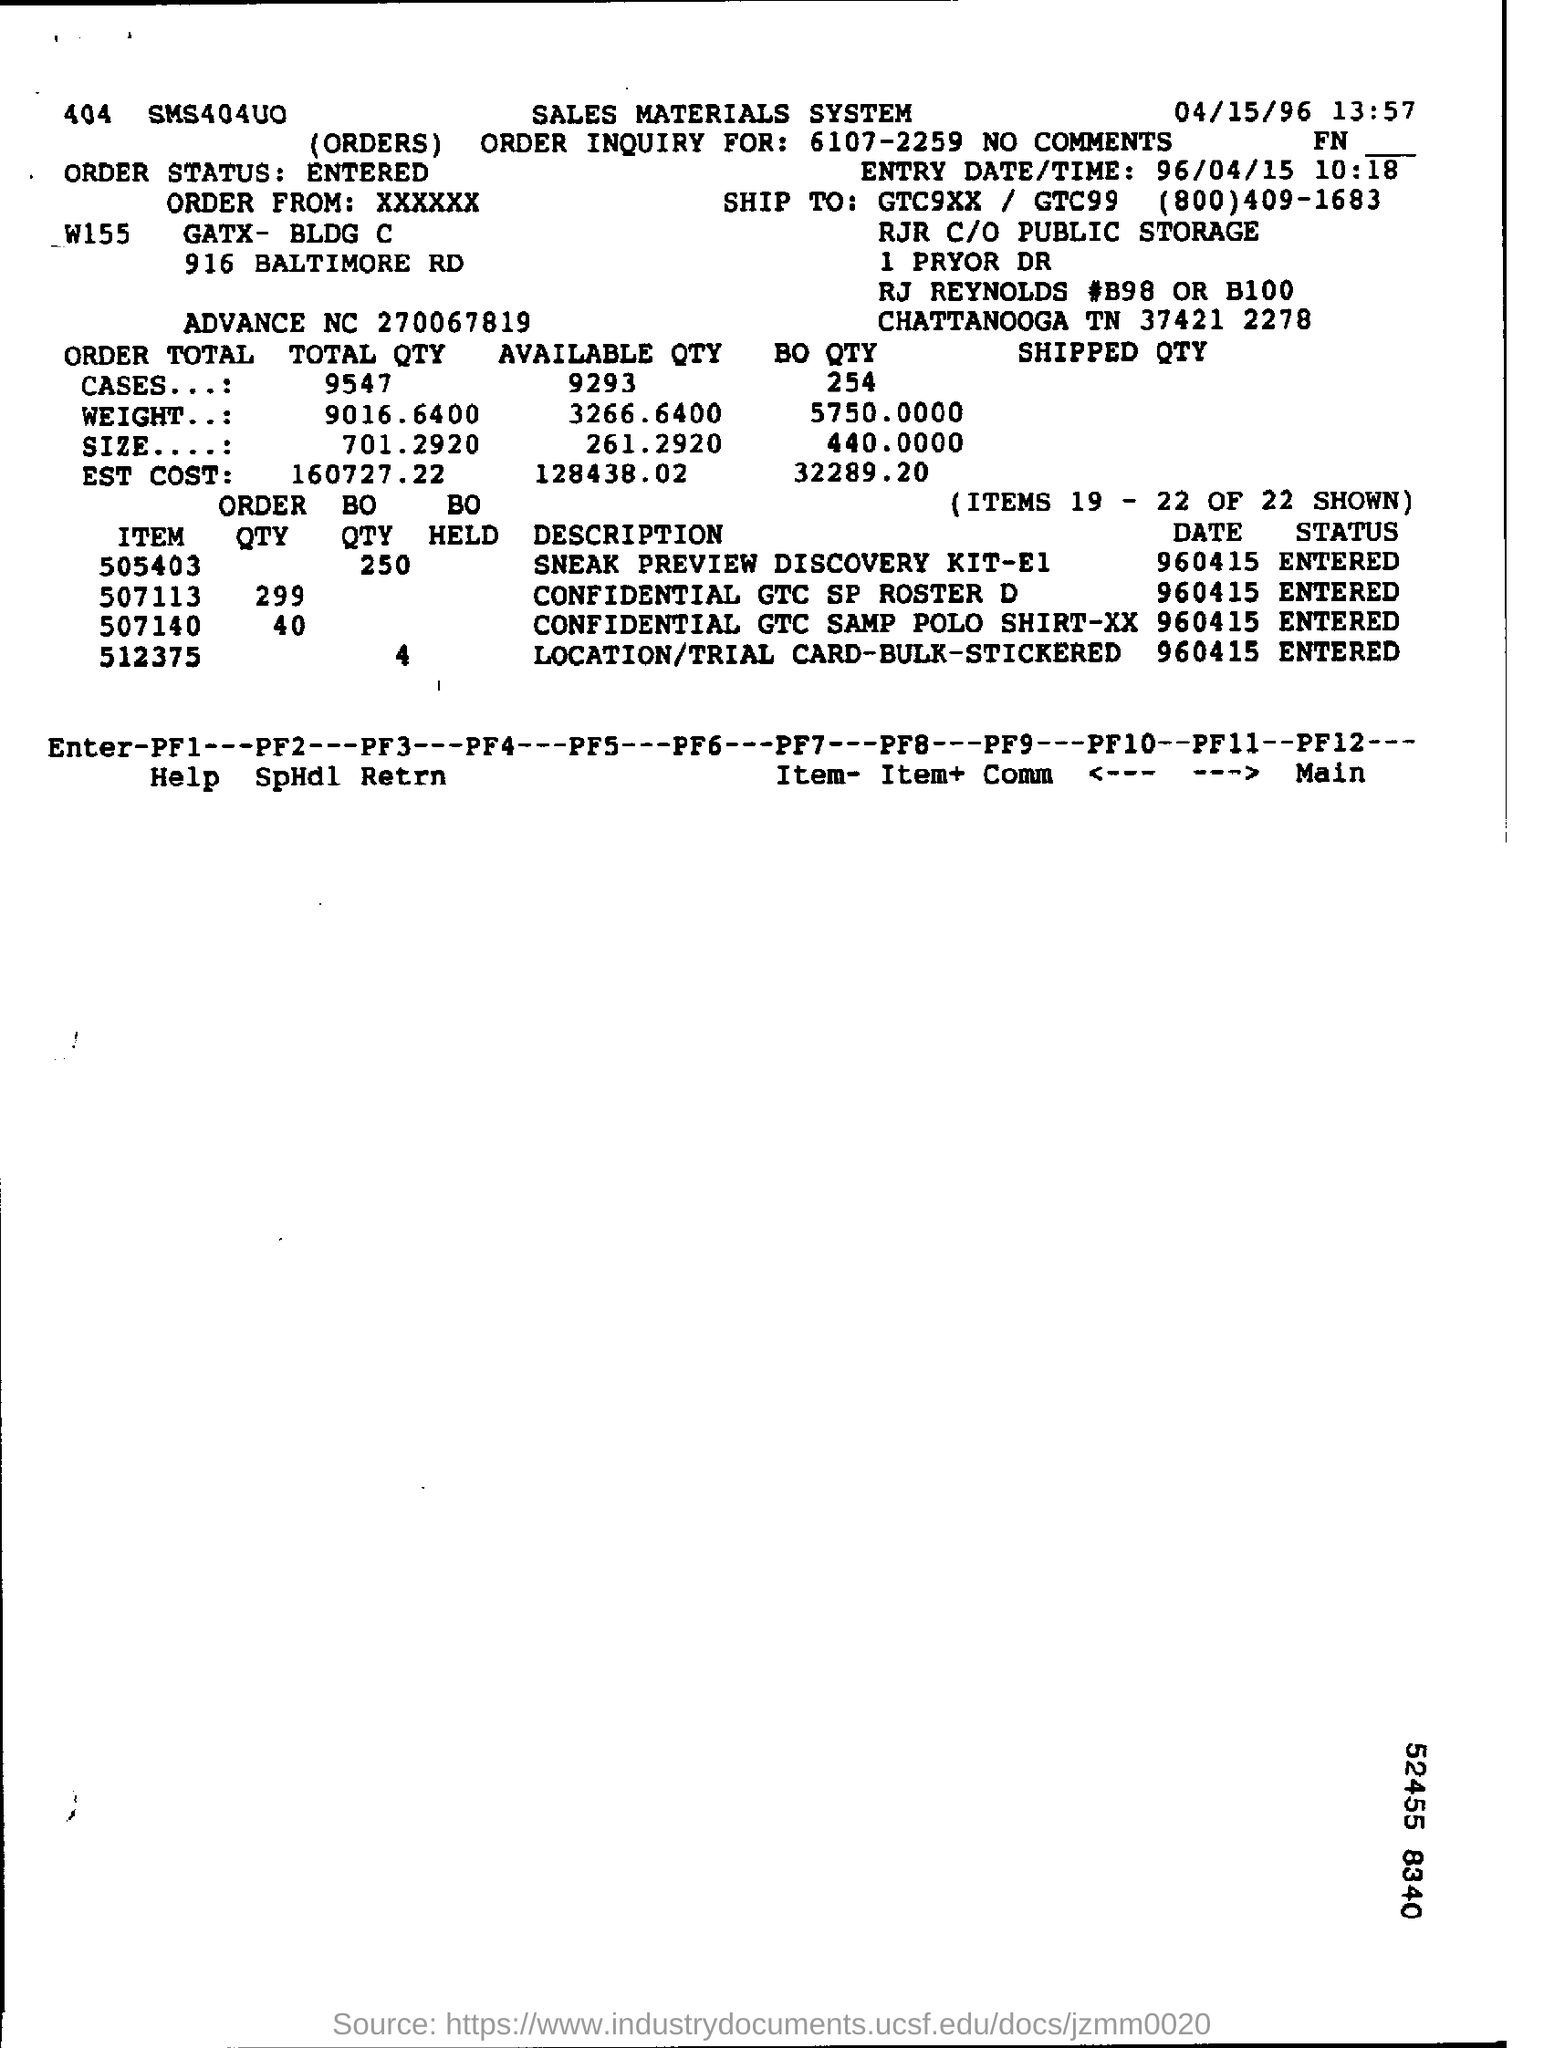Which is the Entry date?
Give a very brief answer. 96/04/15. What is the description of item no 505403?
Your answer should be very brief. SNEAK PREVIEW DISCOVERY KIT-E1. How much is the order qty of 507113?
Your answer should be very brief. 299. 